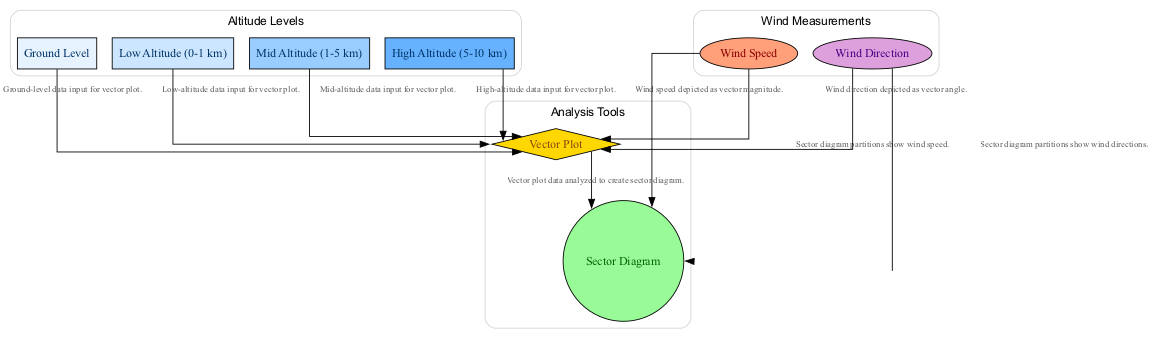What are the altitude levels represented in the diagram? The diagram includes four altitude levels: Ground Level, Low Altitude (0-1 km), Mid Altitude (1-5 km), and High Altitude (5-10 km). These are explicitly labeled in the diagram as separate nodes.
Answer: Ground Level, Low Altitude (0-1 km), Mid Altitude (1-5 km), High Altitude (5-10 km) How many edges connect the altitude levels to the vector plot? Each altitude level (Ground Level, Low Altitude, Mid Altitude, High Altitude) is connected to the vector plot with a directed edge, totaling four edges.
Answer: 4 What does the vector plot illustrate? The vector plot depicts wind speed and direction at various altitudes using graphical representation, as indicated in its description in the diagram.
Answer: Wind speed and direction Which diagram shows the frequency and speed of wind directions? The sector diagram is specifically designed as a circular chart that divides wind direction into sectors while displaying the frequency and speed, as stated in its description.
Answer: Sector Diagram What is the relationship between the vector plot and sector diagram? The vector plot data is analyzed to create the sector diagram, meaning that the sector diagram derives information from the vector plot for its construction.
Answer: Analyzed data How is wind speed depicted in the vector plot? In the vector plot, wind speed is represented by the magnitude of vectors, which indicates how strong the wind is at various altitudes according to the description.
Answer: Vector magnitude How would you describe the connection between wind speed and the sector diagram? Wind speed contributes to the partitioning shown in the sector diagram, which allows understanding of speed variations across different wind directions, establishing a direct relationship between the two.
Answer: Wind speed partitions What colors represent different altitude levels in the diagram? Different shades of blue are used to depict the altitude levels: Ground Level is light blue, Low Altitude is slightly darker, Mid Altitude more so, and High Altitude is the darkest shade.
Answer: Various shades of blue What do the nodes for wind speed and wind direction have in common? Both nodes are types of measurements that feed into both the vector plot and sector diagram, indicating they are foundational components for analyzing wind characteristics depicted in the diagram.
Answer: They feed into vector plot and sector diagram 